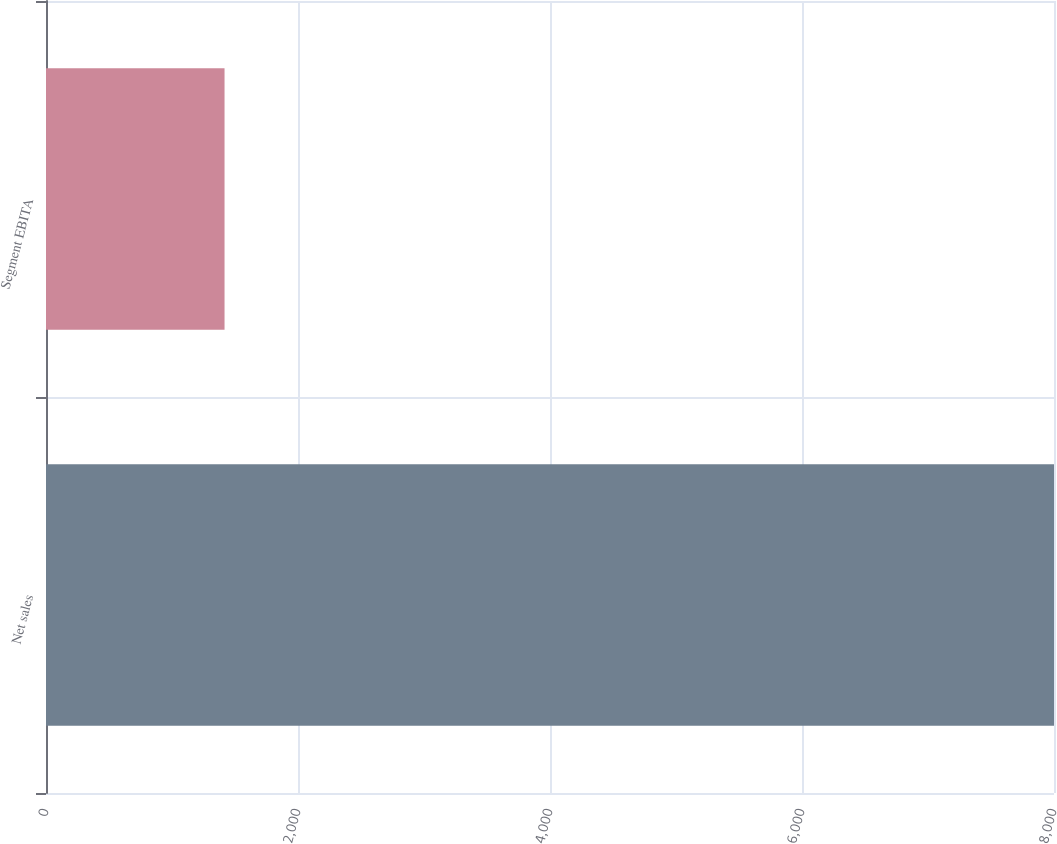Convert chart to OTSL. <chart><loc_0><loc_0><loc_500><loc_500><bar_chart><fcel>Net sales<fcel>Segment EBITA<nl><fcel>8000<fcel>1417<nl></chart> 